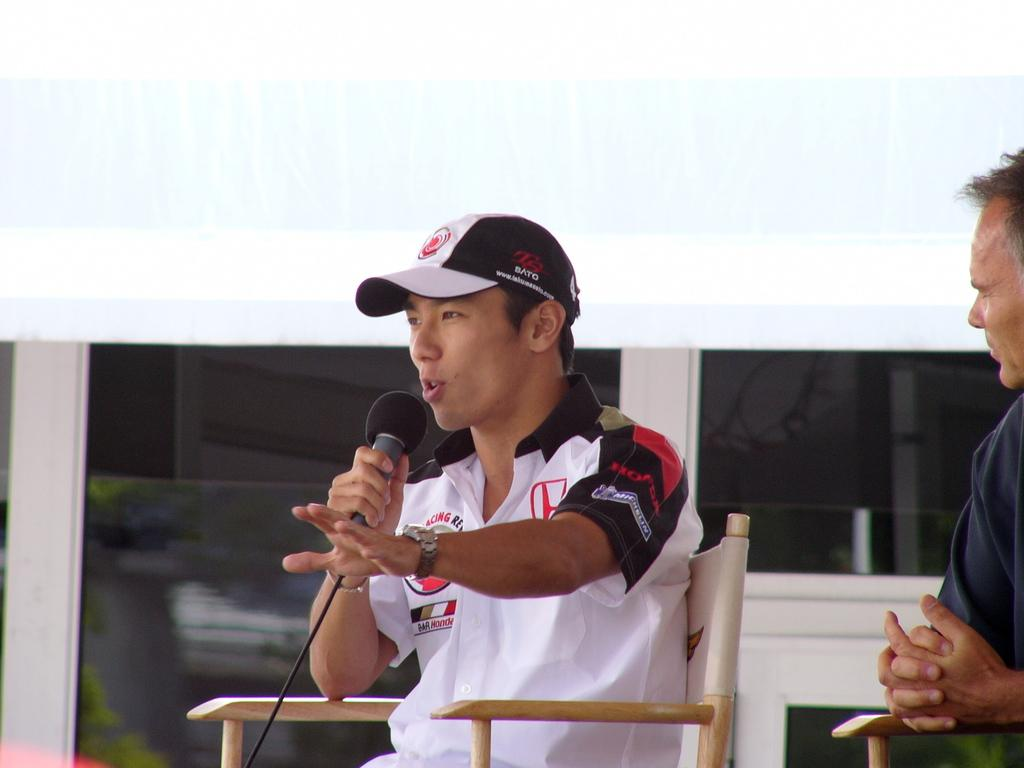How many people are sitting in the chairs in the image? There are two persons sitting on chairs in the image. What is one of the persons holding? One person is holding a microphone. Can you describe the appearance of the person holding the microphone? The person holding the microphone is wearing a cap. What can be seen in the background of the image? There is a glass window in the background. What type of butter is being used to solve the riddle in the image? There is no butter or riddle present in the image. How many sheep can be seen grazing in the background of the image? There are no sheep present in the image; it features two persons sitting on chairs, one holding a microphone, and a glass window in the background. 